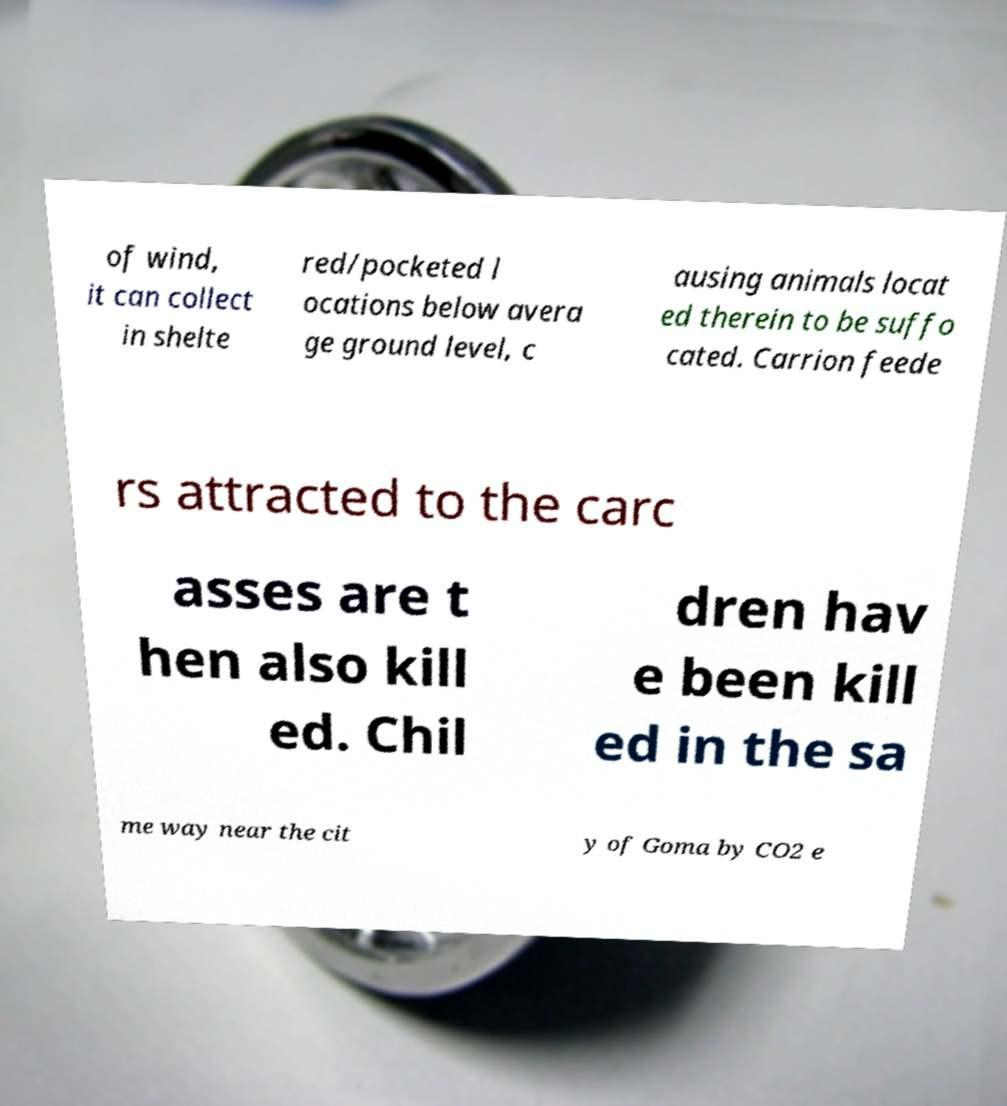I need the written content from this picture converted into text. Can you do that? of wind, it can collect in shelte red/pocketed l ocations below avera ge ground level, c ausing animals locat ed therein to be suffo cated. Carrion feede rs attracted to the carc asses are t hen also kill ed. Chil dren hav e been kill ed in the sa me way near the cit y of Goma by CO2 e 